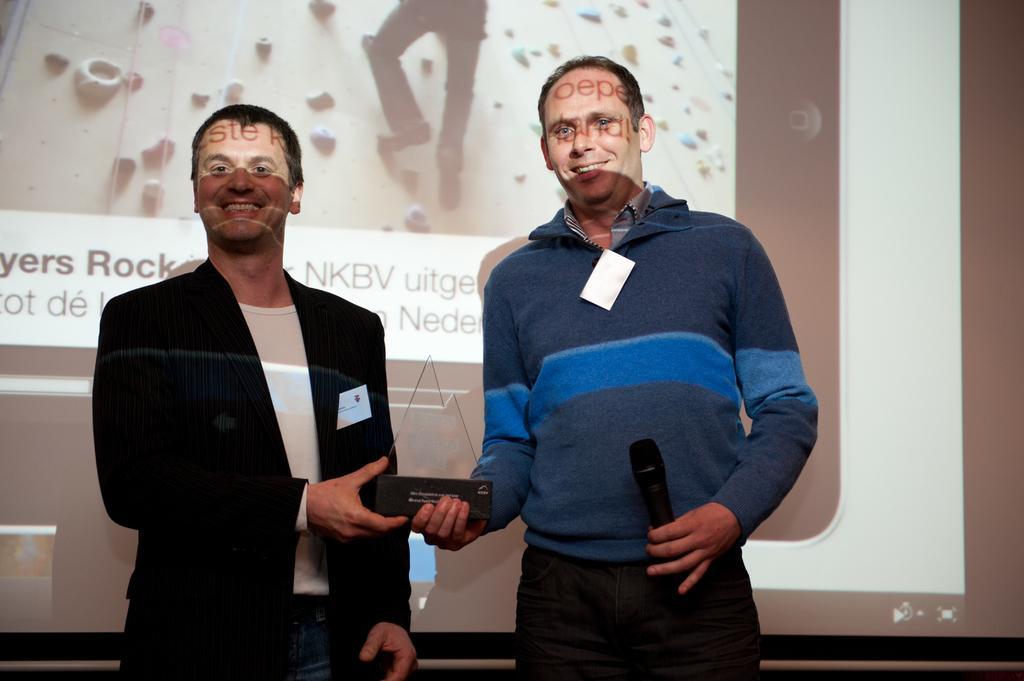Can you describe this image briefly? In this image we can see two persons are standing, and smiling, he is wearing the suit, and holding a microphone in the hands, and holding some object, at back here is the projector. 